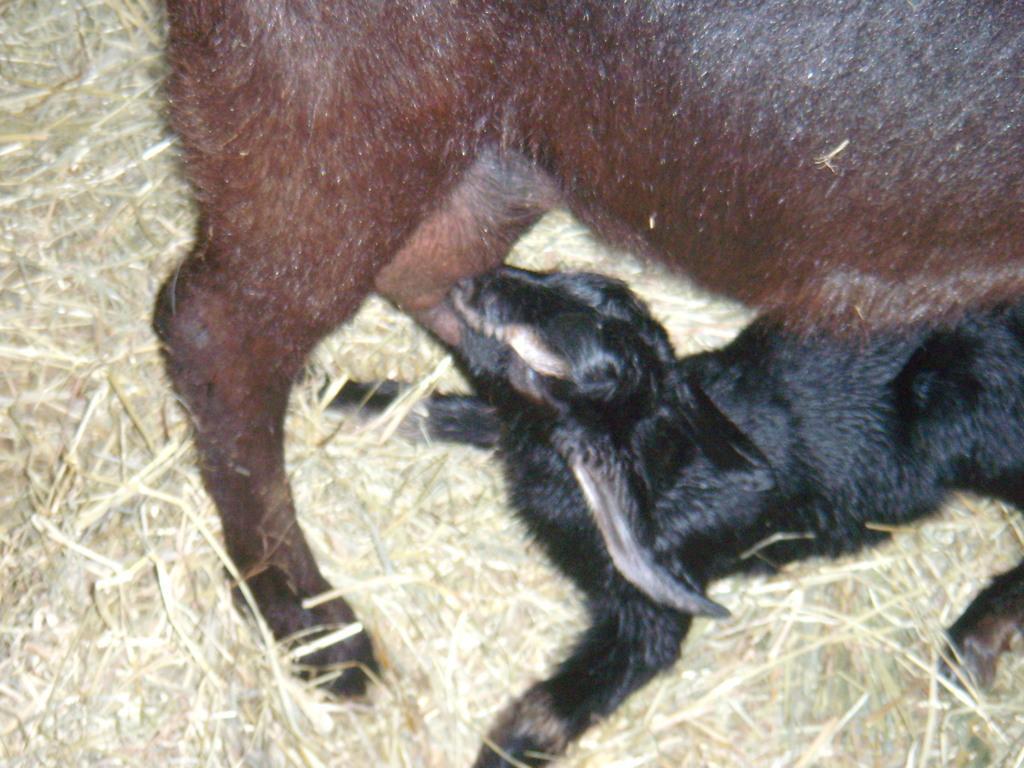In one or two sentences, can you explain what this image depicts? In this image, we can see two animals and there is dried grass. 